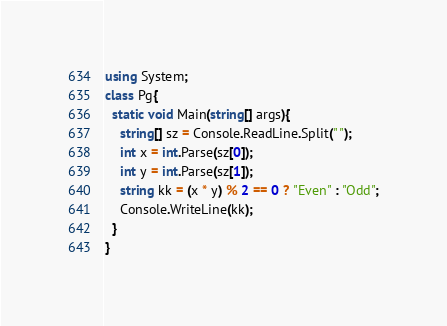Convert code to text. <code><loc_0><loc_0><loc_500><loc_500><_C#_>using System;
class Pg{
  static void Main(string[] args){
    string[] sz = Console.ReadLine.Split(" ");
    int x = int.Parse(sz[0]);
    int y = int.Parse(sz[1]);
    string kk = (x * y) % 2 == 0 ? "Even" : "Odd";
    Console.WriteLine(kk);
  }
}
</code> 